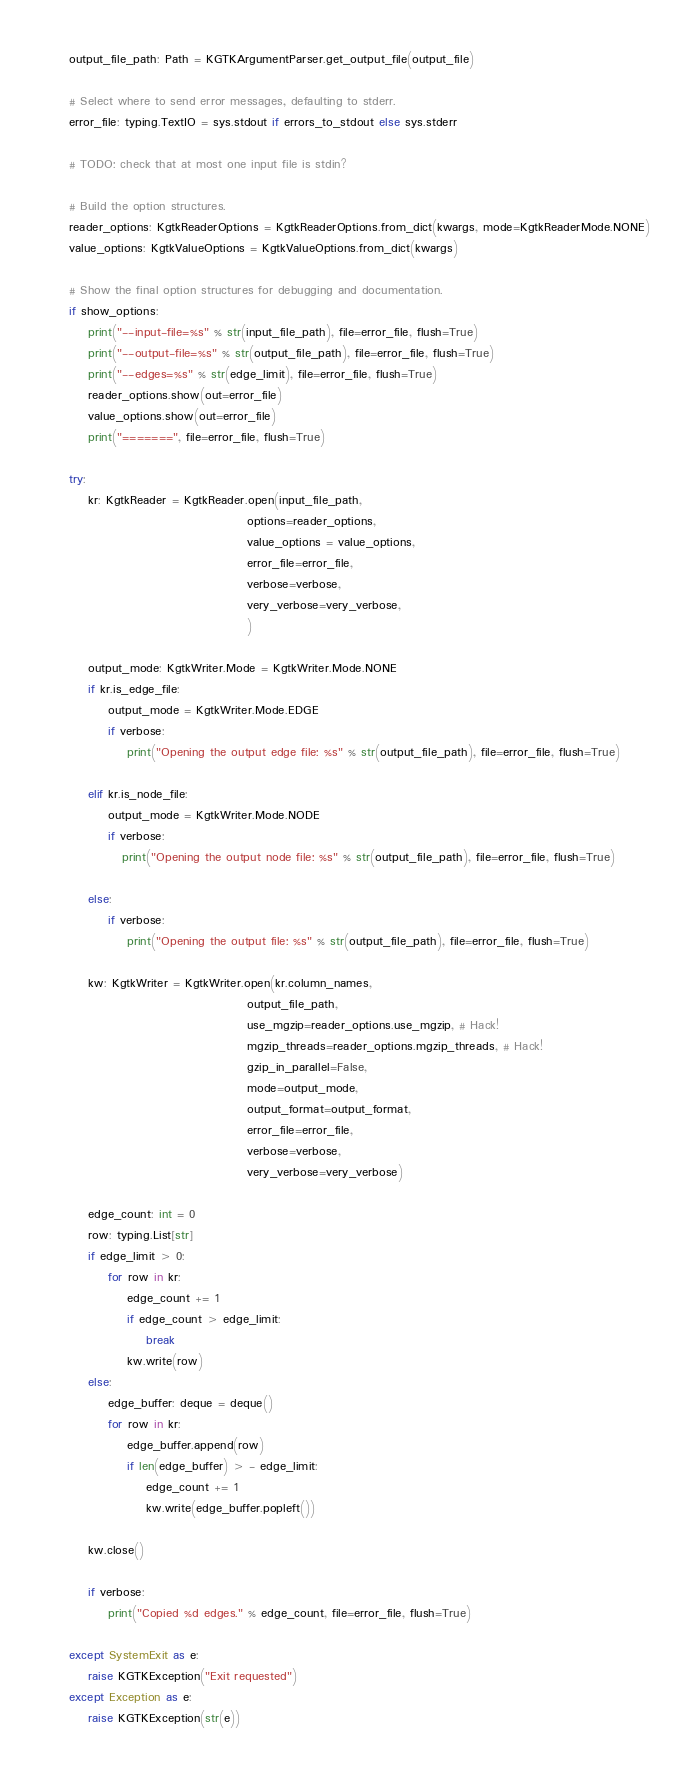Convert code to text. <code><loc_0><loc_0><loc_500><loc_500><_Python_>    output_file_path: Path = KGTKArgumentParser.get_output_file(output_file)

    # Select where to send error messages, defaulting to stderr.
    error_file: typing.TextIO = sys.stdout if errors_to_stdout else sys.stderr

    # TODO: check that at most one input file is stdin?

    # Build the option structures.
    reader_options: KgtkReaderOptions = KgtkReaderOptions.from_dict(kwargs, mode=KgtkReaderMode.NONE)
    value_options: KgtkValueOptions = KgtkValueOptions.from_dict(kwargs)

    # Show the final option structures for debugging and documentation.
    if show_options:
        print("--input-file=%s" % str(input_file_path), file=error_file, flush=True)
        print("--output-file=%s" % str(output_file_path), file=error_file, flush=True)
        print("--edges=%s" % str(edge_limit), file=error_file, flush=True)
        reader_options.show(out=error_file)
        value_options.show(out=error_file)
        print("=======", file=error_file, flush=True)

    try:
        kr: KgtkReader = KgtkReader.open(input_file_path,
                                         options=reader_options,
                                         value_options = value_options,
                                         error_file=error_file,
                                         verbose=verbose,
                                         very_verbose=very_verbose,
                                         )

        output_mode: KgtkWriter.Mode = KgtkWriter.Mode.NONE
        if kr.is_edge_file:
            output_mode = KgtkWriter.Mode.EDGE
            if verbose:
                print("Opening the output edge file: %s" % str(output_file_path), file=error_file, flush=True)

        elif kr.is_node_file:
            output_mode = KgtkWriter.Mode.NODE
            if verbose:
               print("Opening the output node file: %s" % str(output_file_path), file=error_file, flush=True)

        else:
            if verbose:
                print("Opening the output file: %s" % str(output_file_path), file=error_file, flush=True)

        kw: KgtkWriter = KgtkWriter.open(kr.column_names,
                                         output_file_path,
                                         use_mgzip=reader_options.use_mgzip, # Hack!
                                         mgzip_threads=reader_options.mgzip_threads, # Hack!
                                         gzip_in_parallel=False,
                                         mode=output_mode,
                                         output_format=output_format,
                                         error_file=error_file,
                                         verbose=verbose,
                                         very_verbose=very_verbose)

        edge_count: int = 0
        row: typing.List[str]
        if edge_limit > 0:
            for row in kr:
                edge_count += 1
                if edge_count > edge_limit:
                    break
                kw.write(row)
        else:
            edge_buffer: deque = deque()
            for row in kr:
                edge_buffer.append(row)
                if len(edge_buffer) > - edge_limit:
                    edge_count += 1
                    kw.write(edge_buffer.popleft())

        kw.close()

        if verbose:
            print("Copied %d edges." % edge_count, file=error_file, flush=True)

    except SystemExit as e:
        raise KGTKException("Exit requested")
    except Exception as e:
        raise KGTKException(str(e))

</code> 